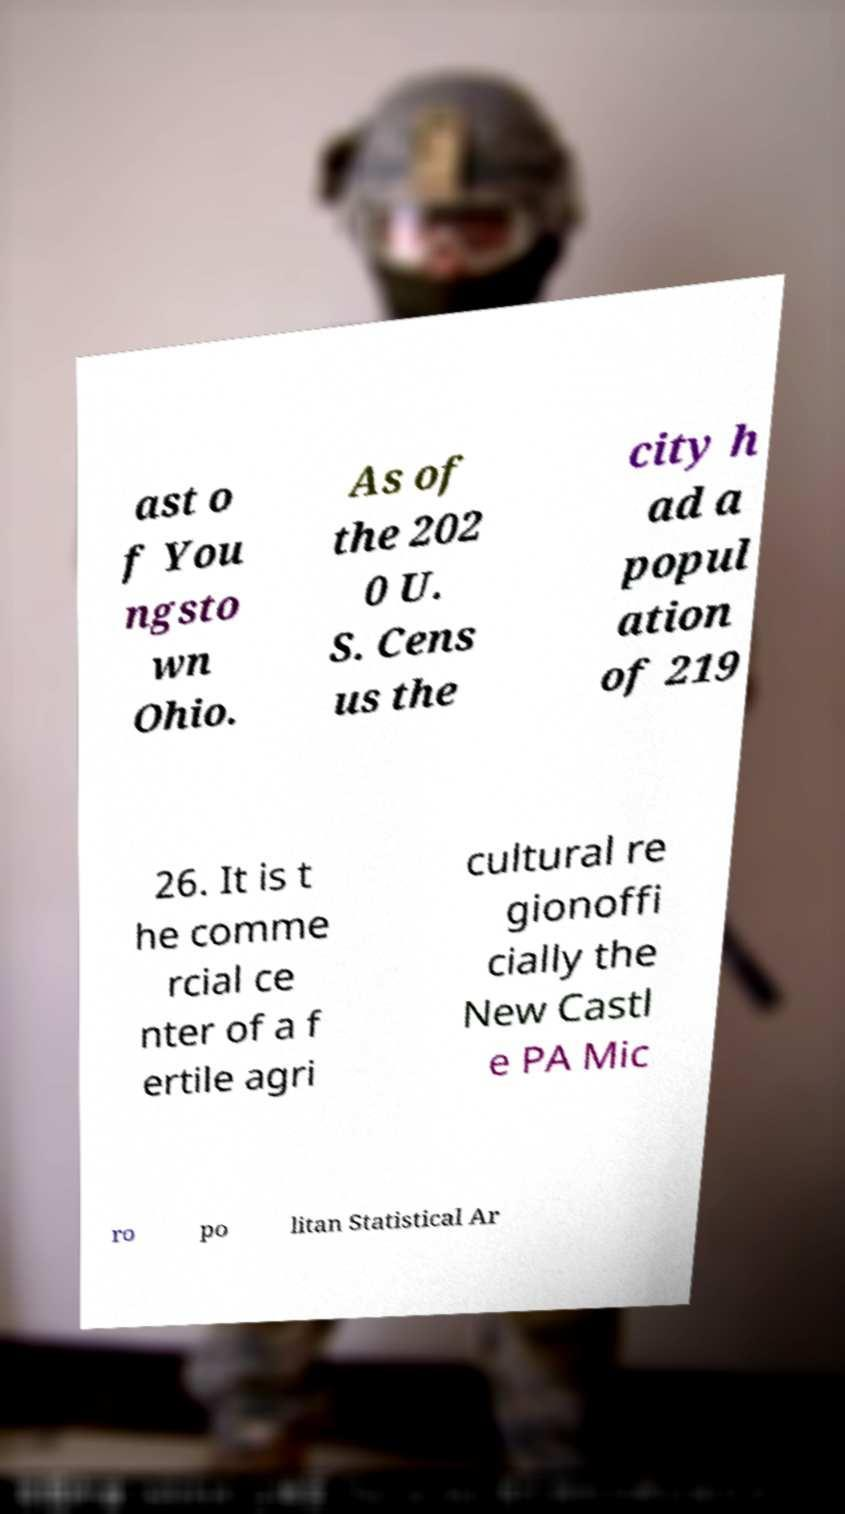Could you assist in decoding the text presented in this image and type it out clearly? ast o f You ngsto wn Ohio. As of the 202 0 U. S. Cens us the city h ad a popul ation of 219 26. It is t he comme rcial ce nter of a f ertile agri cultural re gionoffi cially the New Castl e PA Mic ro po litan Statistical Ar 